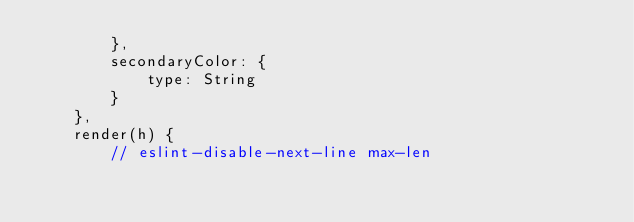<code> <loc_0><loc_0><loc_500><loc_500><_JavaScript_>        },
        secondaryColor: {
            type: String
        }
    },
    render(h) {
        // eslint-disable-next-line max-len</code> 